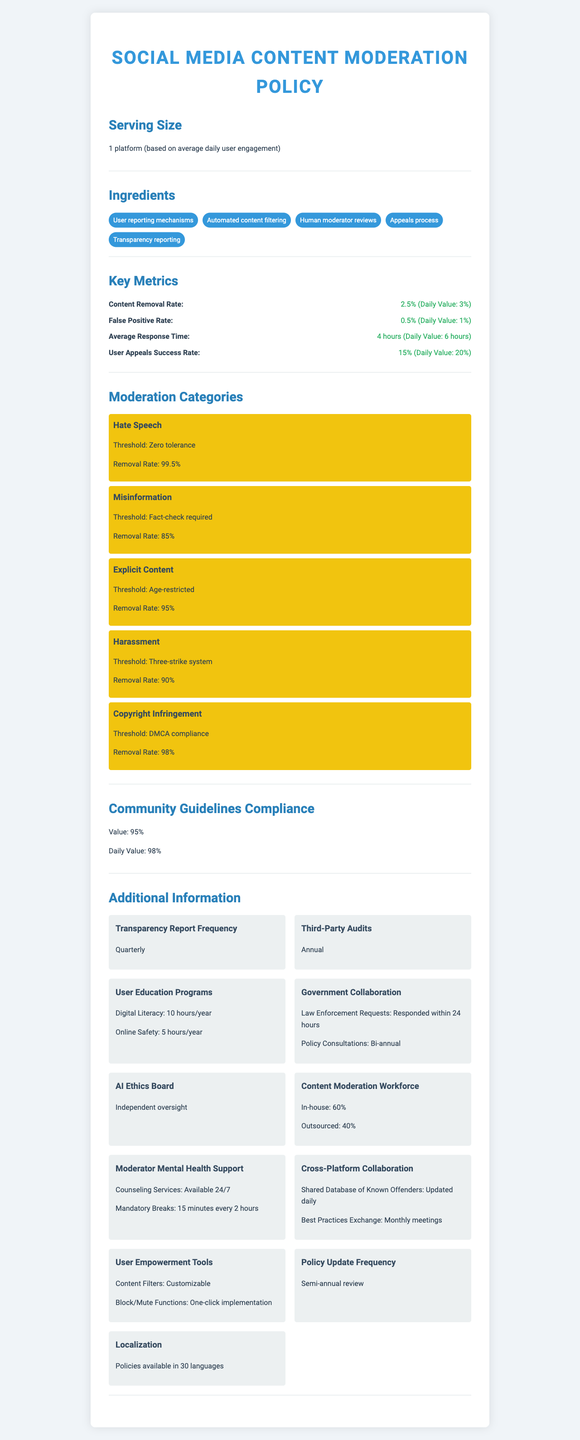what is the average response time for content moderation? The document states that the average response time is 4 hours with a daily value of 6 hours.
Answer: 4 hours What is the percentage of in-house content moderation workforce? The document mentions that the content moderation workforce is composed of 60% in-house moderators.
Answer: 60% Which moderation category has the highest removal rate? A. Hate Speech B. Misinformation C. Explicit Content D. Harassment The removal rate for Hate Speech is 99.5%, which is higher than the rates for the other categories listed.
Answer: A What is the main idea of the document? The document is structured to inform about the various facets of a content moderation policy, including specific metrics, moderation strategies, and support structures for moderators.
Answer: The document provides a comprehensive overview of a social media content moderation policy, detailing key metrics, moderation categories, compliance, additional information, and support mechanisms. What is the user appeal success rate? The document states that the user appeal success rate is 15% with a daily value of 20%.
Answer: 15% Is there a three-strike system for handling harassment content? The document specifies that harassment is managed via a three-strike system.
Answer: Yes How often are transparency reports released? The transparency reports are released quarterly as stated in the document.
Answer: Quarterly What is the content removal rate for copyright infringement? The removal rate for copyright infringement is 98%, according to the data provided.
Answer: 98% What is the threshold for handling explicit content? A. Zero tolerance B. Age-restricted C. Fact-check required D. DMCA compliance The document mentions that the threshold for explicit content is age-restricted.
Answer: B How frequently are the policies updated? The document states that the policy update frequency is semi-annual.
Answer: Semi-annual review How many hours per year are allocated for digital literacy user education programs? The document mentions that 10 hours per year are dedicated to digital literacy in the user education programs.
Answer: 10 hours/year Does the document specify the exact number of human moderators? The document does not provide the exact number of human moderators; it only gives percentages of in-house and outsourced moderators.
Answer: Not enough information Are the content filters customizable for users? The document states that the content filters are customizable for users.
Answer: Yes Describe the role of the AI Ethics Board mentioned in the document. The document notes that an independent AI Ethics Board is in place to oversee ethical considerations within the content moderation process.
Answer: The AI Ethics Board provides independent oversight for the social media content moderation policy. Can the appeals process be answered based on the visual information in the document? The document does not provide detailed information on how the appeals process works, only that there is one in place.
Answer: Cannot be determined 